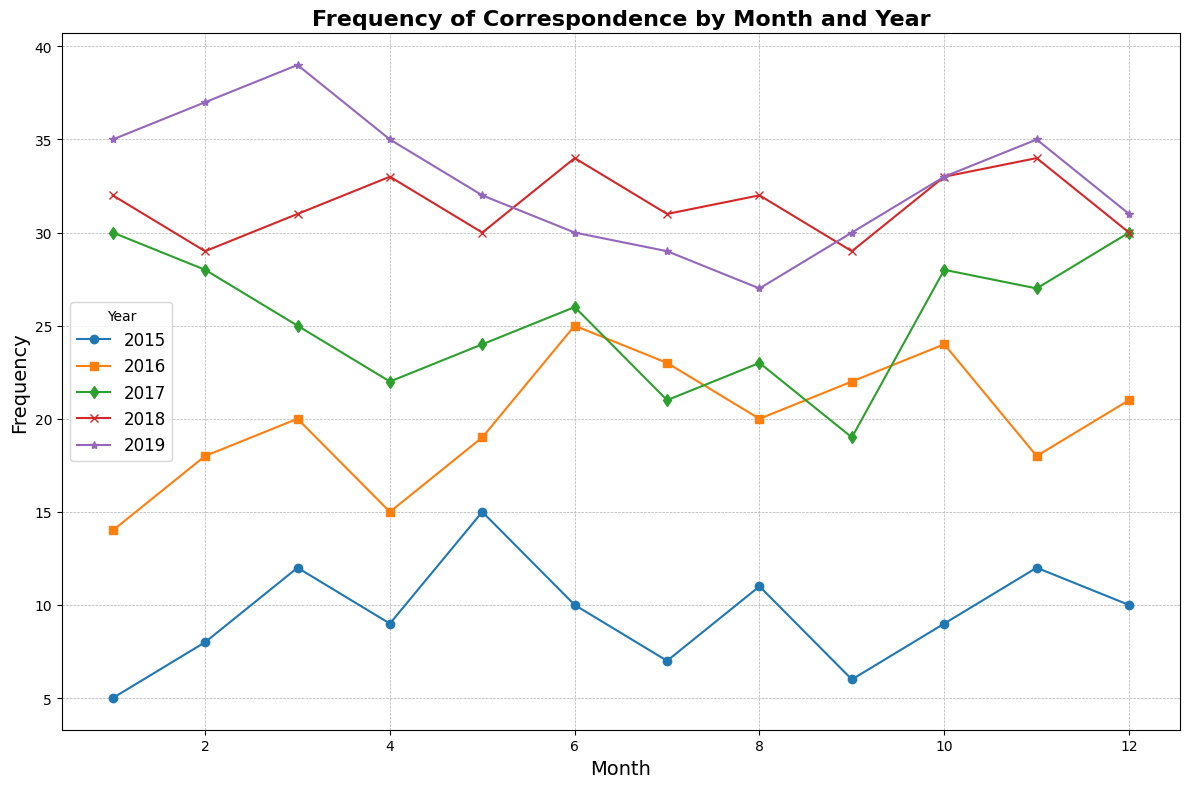What is the month with the highest frequency of correspondence overall? Visually assess the plot and find the month with the highest point across all years. The highest peak on the y-axis represents the maximum frequency.
Answer: January 2019 How did the frequency of correspondence change from January to December in 2016? Track the line corresponding to 2016 and notice the values at January and December. Compare the shapes visually, including peaks and troughs. January starts at 14 and December ends at 21, with various fluctuations between.
Answer: Increased overall Which year had the most stable frequency of correspondence throughout the months? Visually follow each line representing a year. The most stable year will have the least variation between the highest and lowest points. Compare overall trends year by year.
Answer: 2017 In which year was the month of March most frequent compared to other months? Look at the March points for each year and compare their heights. The year with the tallest March point has the highest frequency in that month.
Answer: 2019 What is the average frequency of correspondence across all months in 2018? Sum the frequency values for 2018 and divide by 12 months. This requires adding all monthly frequencies for 2018 and dividing by 12. (32 + 29 + 31 + 33 + 30 + 34 + 31 + 32 + 29 + 33 + 34 + 30 = 378; 378 / 12 = 31.5).
Answer: 31.5 Which year had the largest increase in frequency from January to February? Compare the difference between January and February for each year by checking the heights. Calculate each difference and observe the greatest increase.
Answer: 2019 How does the frequency in December 2019 compare to December 2017? Observe both points corresponding to December 2017 and 2019, and compare their heights. December 2019 shows 31, and December 2017 shows 30.
Answer: Higher in 2019 What is the total correspondence frequency for the year 2015? Sum the frequency values from January to December for 2015. 5 + 8 + 12 + 9 + 15 + 10 + 7 + 11 + 6 + 9 + 12 + 10 = 114
Answer: 114 In which year did the frequency in August see the largest drop compared to the previous month? Look at the August points and compare their values with July from the same year. Calculate the difference and find the largest drop.
Answer: 2016 